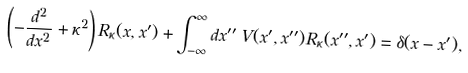<formula> <loc_0><loc_0><loc_500><loc_500>\left ( - \frac { d ^ { 2 } } { d x ^ { 2 } } + \kappa ^ { 2 } \right ) R _ { \kappa } ( x , x ^ { \prime } ) + \int _ { - \infty } ^ { \infty } d x ^ { \prime \prime } \, V ( x ^ { \prime } , x ^ { \prime \prime } ) R _ { \kappa } ( x ^ { \prime \prime } , x ^ { \prime } ) = \delta ( x - x ^ { \prime } ) ,</formula> 